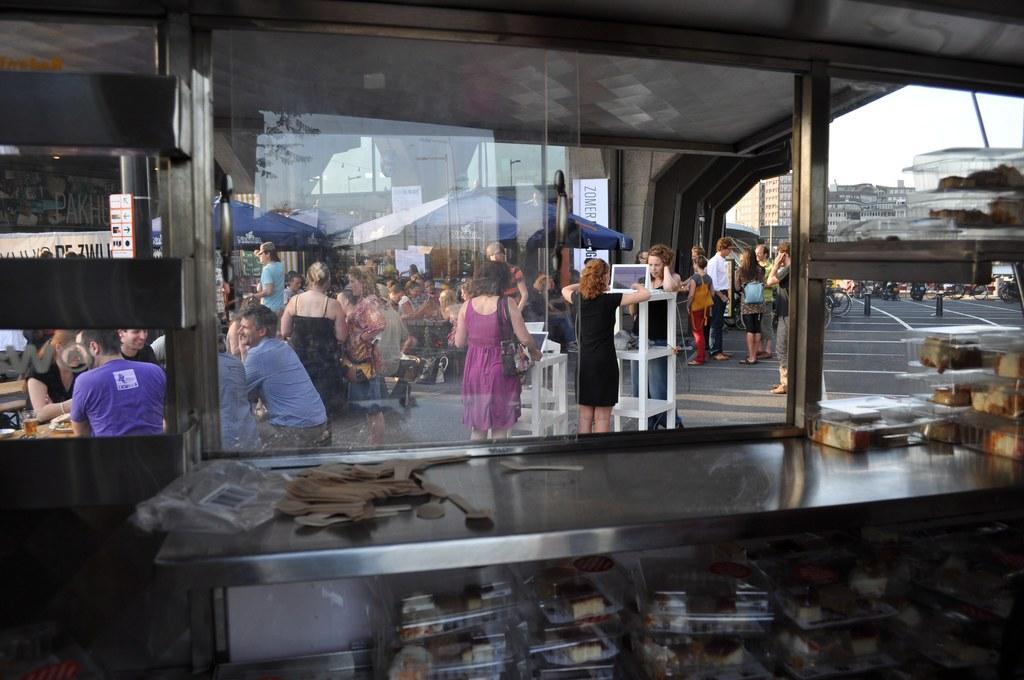Please provide a concise description of this image. We can see glass windows and we can see boxes with food,spoons and objects on the table,under the table we can see boxes with food,through this glass windows we can see people,laptops and objects on tables,tents,buildings,road,board on a wall and sky. 